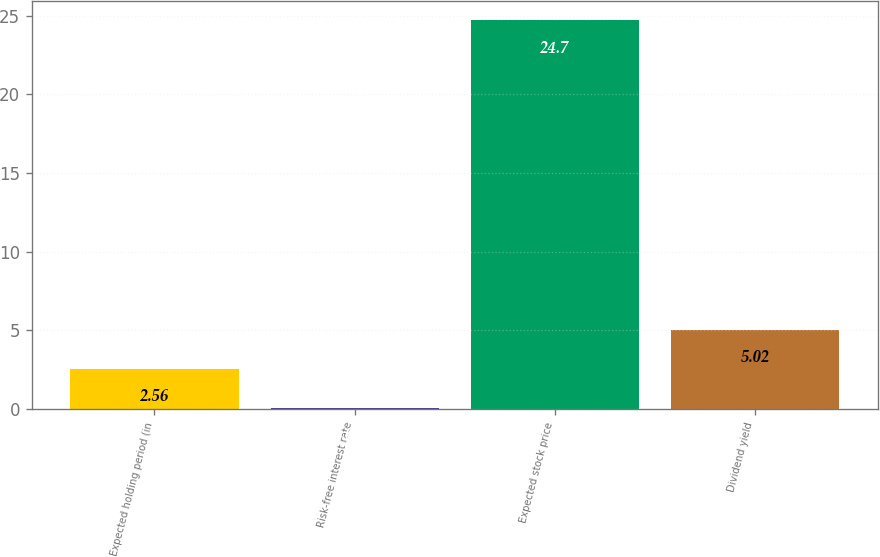<chart> <loc_0><loc_0><loc_500><loc_500><bar_chart><fcel>Expected holding period (in<fcel>Risk-free interest rate<fcel>Expected stock price<fcel>Dividend yield<nl><fcel>2.56<fcel>0.1<fcel>24.7<fcel>5.02<nl></chart> 